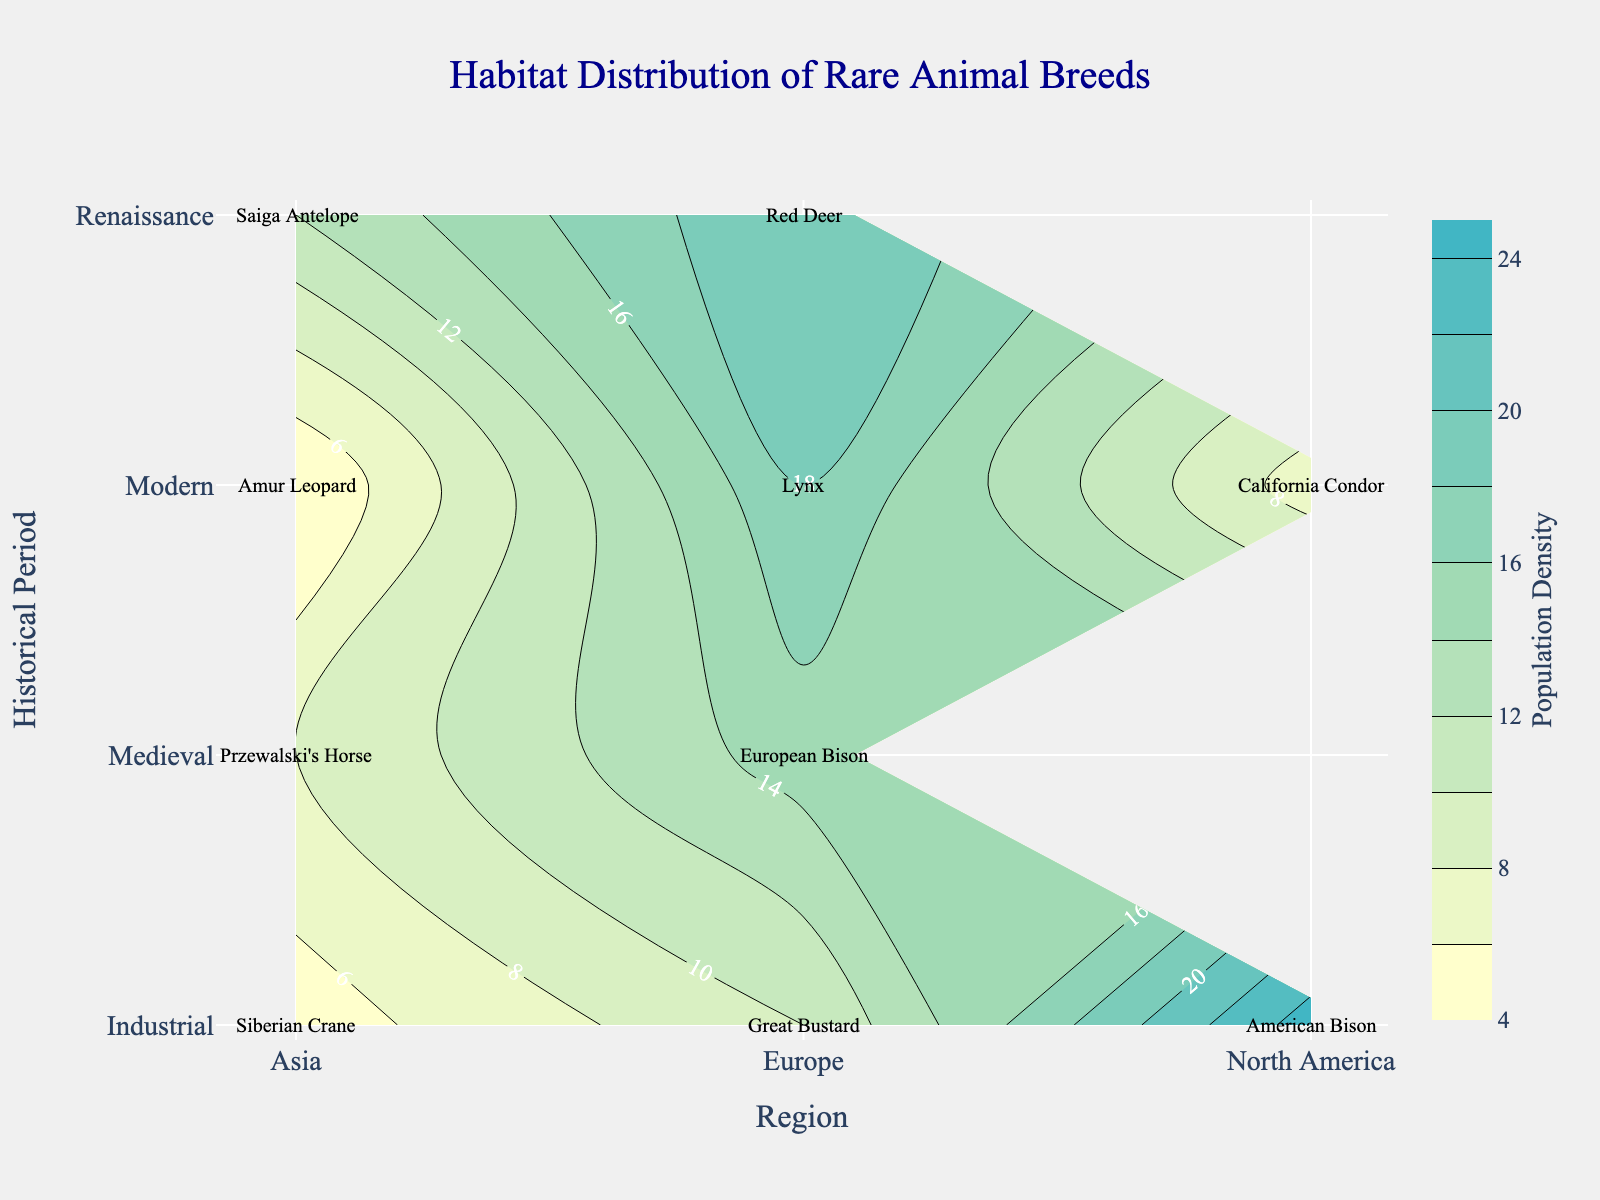What's the title of the plot? The title can be found prominently at the top center of the plot, usually in a larger and bold font for better visibility. From the provided code, the title is "Habitat Distribution of Rare Animal Breeds".
Answer: Habitat Distribution of Rare Animal Breeds Which species has the highest population density in the Industrial period? Refer to the labels on the plot within the Industrial period section. Compare the population densities of American Bison, Great Bustard, and Siberian Crane. American Bison has the highest population density, which is 25.
Answer: American Bison What regions are represented in the Medieval period? Look at the labels within the contour plot under the Medieval period. The regions labeled are Europe and Asia.
Answer: Europe and Asia Compare the population density of Red Deer in the Renaissance period to that of American Bison in the Industrial period. Which is higher? Locate the labeled population densities for Red Deer and American Bison in their respective periods. Red Deer in the Renaissance has a population density of 20, while American Bison in the Industrial period has a population density of 25. Therefore, American Bison has a higher population density.
Answer: American Bison What period and region have the smallest population density on the plot? Examine all periods and regions to identify the smallest population density value. The smallest value is for the Amur Leopard in the Asia region during the Modern period, with a density of 4.
Answer: Modern period, Asia How many different species are represented in the Modern period? Count the number of unique species labels within the Modern period section. The species represented are California Condor, Lynx, and Amur Leopard, totalling three.
Answer: Three What is the average population density of species in the Medieval period? Add the population densities of European Bison (15) and Przewalski's Horse (8), then divide by the number of species (2). The calculation is (15 + 8) / 2 = 11.5.
Answer: 11.5 In which region and period is the Great Bustard found, and what is its population density? Locate the label for Great Bustard on the plot. It is found in the Industrial period in the Europe region, with a population density of 10.
Answer: Industrial period, Europe, 10 Which species is found in Asia during the Industrial period, and what is its population density? Look at the label within the Asia region for the Industrial period. The species is the Siberian Crane with a population density of 5.
Answer: Siberian Crane, 5 What is the trend in population density for Europe across the historical periods from Medieval to Modern? Observe the population densities in the Europe region across the periods. They are 15 (Medieval), 20 (Renaissance), 10 (Industrial), and 18 (Modern). The trend shows an initial increase from Medieval to Renaissance, a decrease during the Industrial period, and a subsequent increase in the Modern period.
Answer: Increase, decrease, increase 